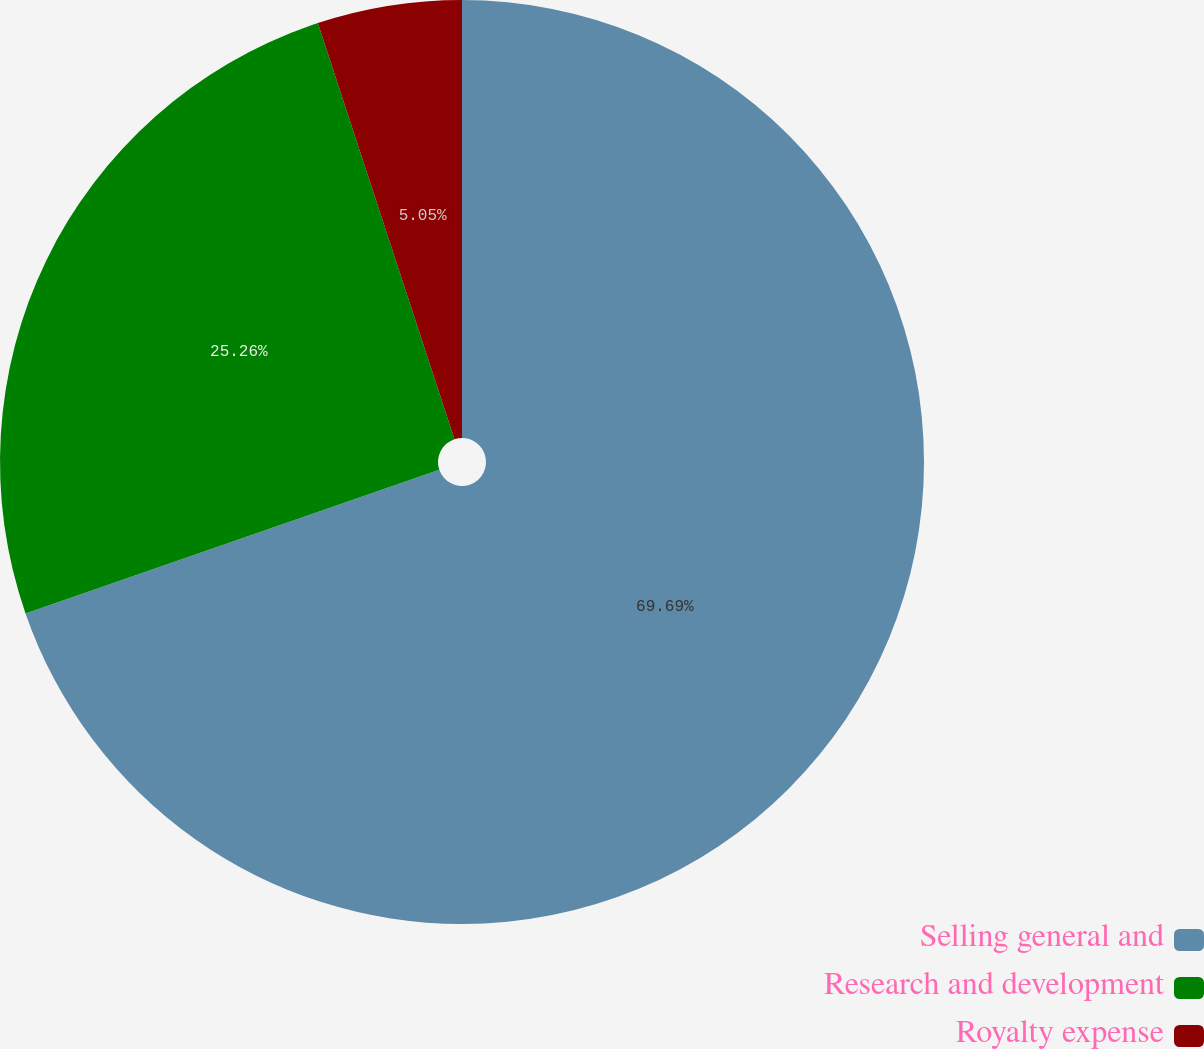<chart> <loc_0><loc_0><loc_500><loc_500><pie_chart><fcel>Selling general and<fcel>Research and development<fcel>Royalty expense<nl><fcel>69.68%<fcel>25.26%<fcel>5.05%<nl></chart> 